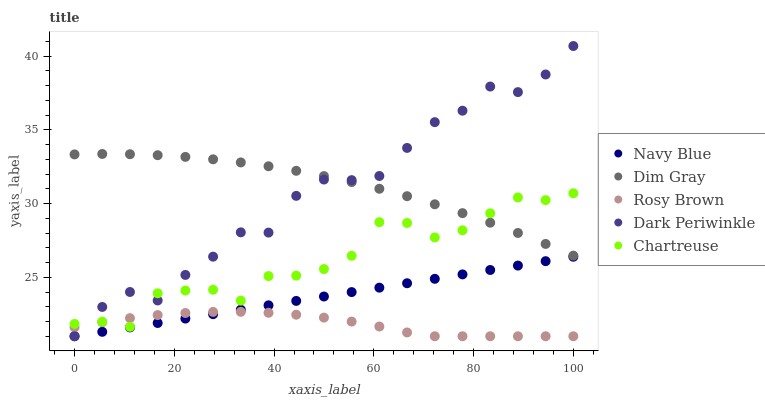Does Rosy Brown have the minimum area under the curve?
Answer yes or no. Yes. Does Dim Gray have the maximum area under the curve?
Answer yes or no. Yes. Does Dim Gray have the minimum area under the curve?
Answer yes or no. No. Does Rosy Brown have the maximum area under the curve?
Answer yes or no. No. Is Navy Blue the smoothest?
Answer yes or no. Yes. Is Dark Periwinkle the roughest?
Answer yes or no. Yes. Is Rosy Brown the smoothest?
Answer yes or no. No. Is Rosy Brown the roughest?
Answer yes or no. No. Does Navy Blue have the lowest value?
Answer yes or no. Yes. Does Dim Gray have the lowest value?
Answer yes or no. No. Does Dark Periwinkle have the highest value?
Answer yes or no. Yes. Does Dim Gray have the highest value?
Answer yes or no. No. Is Rosy Brown less than Dim Gray?
Answer yes or no. Yes. Is Dim Gray greater than Navy Blue?
Answer yes or no. Yes. Does Dark Periwinkle intersect Dim Gray?
Answer yes or no. Yes. Is Dark Periwinkle less than Dim Gray?
Answer yes or no. No. Is Dark Periwinkle greater than Dim Gray?
Answer yes or no. No. Does Rosy Brown intersect Dim Gray?
Answer yes or no. No. 